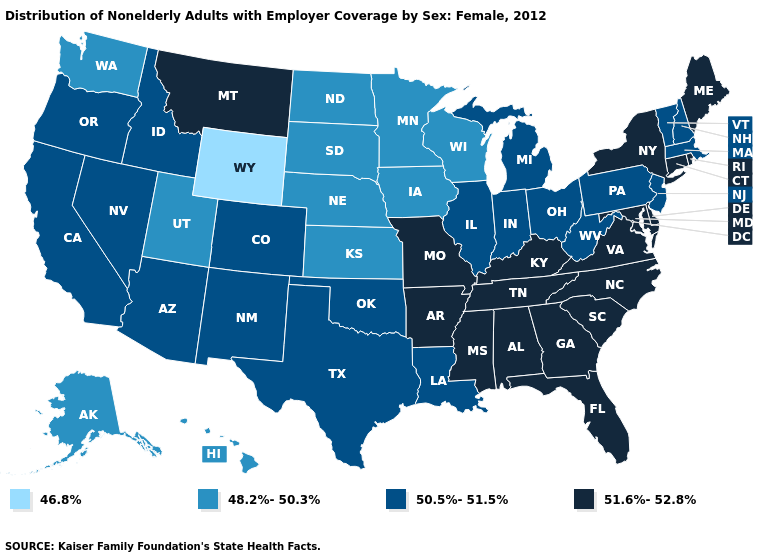Among the states that border Illinois , which have the lowest value?
Give a very brief answer. Iowa, Wisconsin. Name the states that have a value in the range 51.6%-52.8%?
Short answer required. Alabama, Arkansas, Connecticut, Delaware, Florida, Georgia, Kentucky, Maine, Maryland, Mississippi, Missouri, Montana, New York, North Carolina, Rhode Island, South Carolina, Tennessee, Virginia. Among the states that border Virginia , does Kentucky have the lowest value?
Concise answer only. No. Is the legend a continuous bar?
Write a very short answer. No. Does New York have the lowest value in the Northeast?
Answer briefly. No. Among the states that border Virginia , which have the highest value?
Answer briefly. Kentucky, Maryland, North Carolina, Tennessee. Which states have the lowest value in the USA?
Short answer required. Wyoming. Name the states that have a value in the range 48.2%-50.3%?
Short answer required. Alaska, Hawaii, Iowa, Kansas, Minnesota, Nebraska, North Dakota, South Dakota, Utah, Washington, Wisconsin. Which states have the highest value in the USA?
Write a very short answer. Alabama, Arkansas, Connecticut, Delaware, Florida, Georgia, Kentucky, Maine, Maryland, Mississippi, Missouri, Montana, New York, North Carolina, Rhode Island, South Carolina, Tennessee, Virginia. Which states have the lowest value in the Northeast?
Write a very short answer. Massachusetts, New Hampshire, New Jersey, Pennsylvania, Vermont. Which states have the highest value in the USA?
Answer briefly. Alabama, Arkansas, Connecticut, Delaware, Florida, Georgia, Kentucky, Maine, Maryland, Mississippi, Missouri, Montana, New York, North Carolina, Rhode Island, South Carolina, Tennessee, Virginia. Name the states that have a value in the range 50.5%-51.5%?
Keep it brief. Arizona, California, Colorado, Idaho, Illinois, Indiana, Louisiana, Massachusetts, Michigan, Nevada, New Hampshire, New Jersey, New Mexico, Ohio, Oklahoma, Oregon, Pennsylvania, Texas, Vermont, West Virginia. Which states have the highest value in the USA?
Answer briefly. Alabama, Arkansas, Connecticut, Delaware, Florida, Georgia, Kentucky, Maine, Maryland, Mississippi, Missouri, Montana, New York, North Carolina, Rhode Island, South Carolina, Tennessee, Virginia. Among the states that border Iowa , does Missouri have the highest value?
Be succinct. Yes. Does Wyoming have the lowest value in the USA?
Give a very brief answer. Yes. 